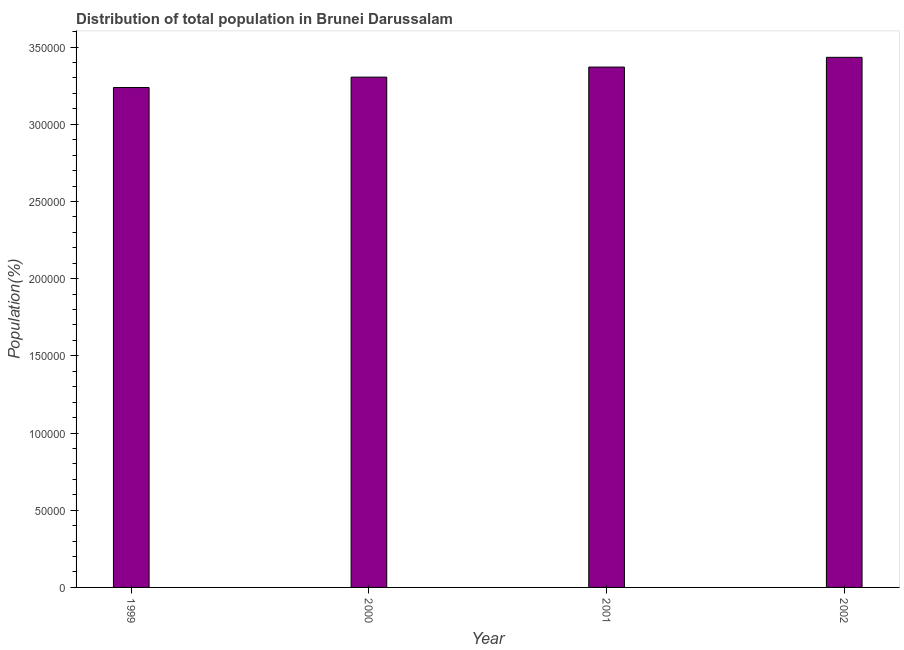Does the graph contain any zero values?
Ensure brevity in your answer.  No. Does the graph contain grids?
Provide a succinct answer. No. What is the title of the graph?
Offer a terse response. Distribution of total population in Brunei Darussalam . What is the label or title of the Y-axis?
Offer a terse response. Population(%). What is the population in 2000?
Offer a terse response. 3.31e+05. Across all years, what is the maximum population?
Provide a short and direct response. 3.43e+05. Across all years, what is the minimum population?
Keep it short and to the point. 3.24e+05. In which year was the population minimum?
Offer a very short reply. 1999. What is the sum of the population?
Keep it short and to the point. 1.33e+06. What is the difference between the population in 1999 and 2001?
Provide a succinct answer. -1.33e+04. What is the average population per year?
Provide a succinct answer. 3.34e+05. What is the median population?
Offer a very short reply. 3.34e+05. Do a majority of the years between 1999 and 2001 (inclusive) have population greater than 10000 %?
Your answer should be compact. Yes. What is the ratio of the population in 1999 to that in 2001?
Provide a succinct answer. 0.96. Is the difference between the population in 2000 and 2002 greater than the difference between any two years?
Offer a terse response. No. What is the difference between the highest and the second highest population?
Keep it short and to the point. 6309. What is the difference between the highest and the lowest population?
Keep it short and to the point. 1.96e+04. How many bars are there?
Your answer should be very brief. 4. Are all the bars in the graph horizontal?
Provide a short and direct response. No. Are the values on the major ticks of Y-axis written in scientific E-notation?
Ensure brevity in your answer.  No. What is the Population(%) in 1999?
Ensure brevity in your answer.  3.24e+05. What is the Population(%) in 2000?
Your response must be concise. 3.31e+05. What is the Population(%) of 2001?
Ensure brevity in your answer.  3.37e+05. What is the Population(%) of 2002?
Make the answer very short. 3.43e+05. What is the difference between the Population(%) in 1999 and 2000?
Provide a succinct answer. -6742. What is the difference between the Population(%) in 1999 and 2001?
Give a very brief answer. -1.33e+04. What is the difference between the Population(%) in 1999 and 2002?
Your response must be concise. -1.96e+04. What is the difference between the Population(%) in 2000 and 2001?
Your answer should be very brief. -6520. What is the difference between the Population(%) in 2000 and 2002?
Provide a short and direct response. -1.28e+04. What is the difference between the Population(%) in 2001 and 2002?
Make the answer very short. -6309. What is the ratio of the Population(%) in 1999 to that in 2000?
Offer a terse response. 0.98. What is the ratio of the Population(%) in 1999 to that in 2001?
Offer a terse response. 0.96. What is the ratio of the Population(%) in 1999 to that in 2002?
Offer a terse response. 0.94. What is the ratio of the Population(%) in 2000 to that in 2002?
Your answer should be compact. 0.96. 